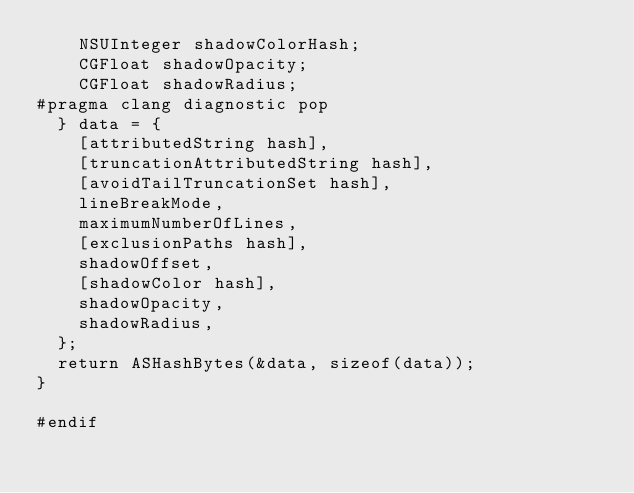Convert code to text. <code><loc_0><loc_0><loc_500><loc_500><_ObjectiveC_>    NSUInteger shadowColorHash;
    CGFloat shadowOpacity;
    CGFloat shadowRadius;
#pragma clang diagnostic pop
  } data = {
    [attributedString hash],
    [truncationAttributedString hash],
    [avoidTailTruncationSet hash],
    lineBreakMode,
    maximumNumberOfLines,
    [exclusionPaths hash],
    shadowOffset,
    [shadowColor hash],
    shadowOpacity,
    shadowRadius,
  };
  return ASHashBytes(&data, sizeof(data));
}

#endif
</code> 